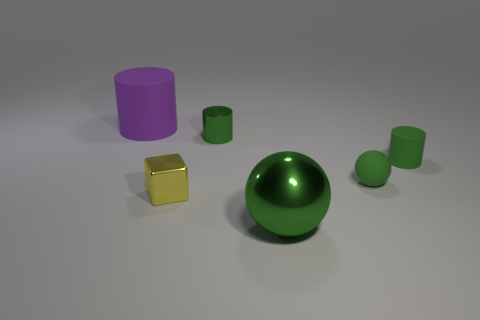Add 2 tiny green spheres. How many objects exist? 8 Subtract all cubes. How many objects are left? 5 Add 4 small cylinders. How many small cylinders exist? 6 Subtract 0 cyan cylinders. How many objects are left? 6 Subtract all big purple things. Subtract all matte cylinders. How many objects are left? 3 Add 3 green balls. How many green balls are left? 5 